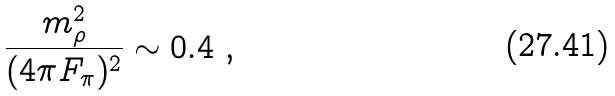Convert formula to latex. <formula><loc_0><loc_0><loc_500><loc_500>\frac { m _ { \rho } ^ { 2 } } { ( 4 \pi F _ { \pi } ) ^ { 2 } } \sim 0 . 4 \ ,</formula> 